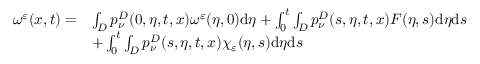<formula> <loc_0><loc_0><loc_500><loc_500>\begin{array} { r l } { \omega ^ { \varepsilon } ( x , t ) = } & { \int _ { D } p _ { \nu } ^ { D } ( 0 , \eta , t , x ) \omega ^ { \varepsilon } ( \eta , 0 ) d \eta + \int _ { 0 } ^ { t } \int _ { D } p _ { \nu } ^ { D } ( s , \eta , t , x ) F ( \eta , s ) d \eta d s } \\ & { + \int _ { 0 } ^ { t } \int _ { D } p _ { \nu } ^ { D } ( s , \eta , t , x ) \chi _ { \varepsilon } ( \eta , s ) d \eta d s } \end{array}</formula> 